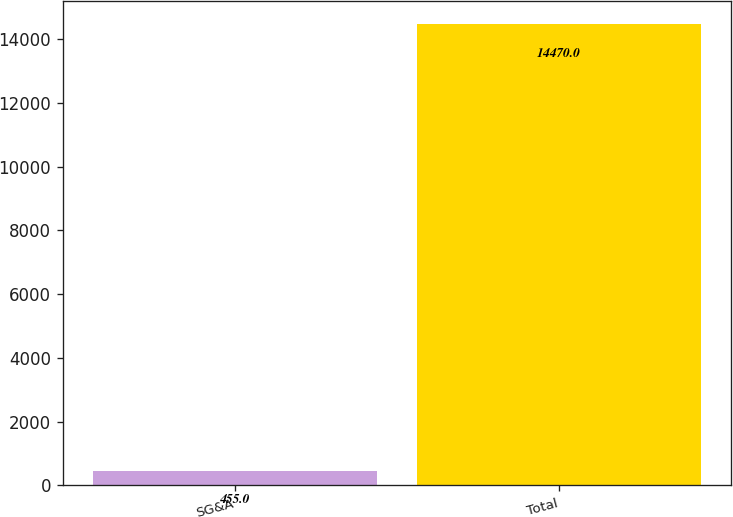<chart> <loc_0><loc_0><loc_500><loc_500><bar_chart><fcel>SG&A<fcel>Total<nl><fcel>455<fcel>14470<nl></chart> 